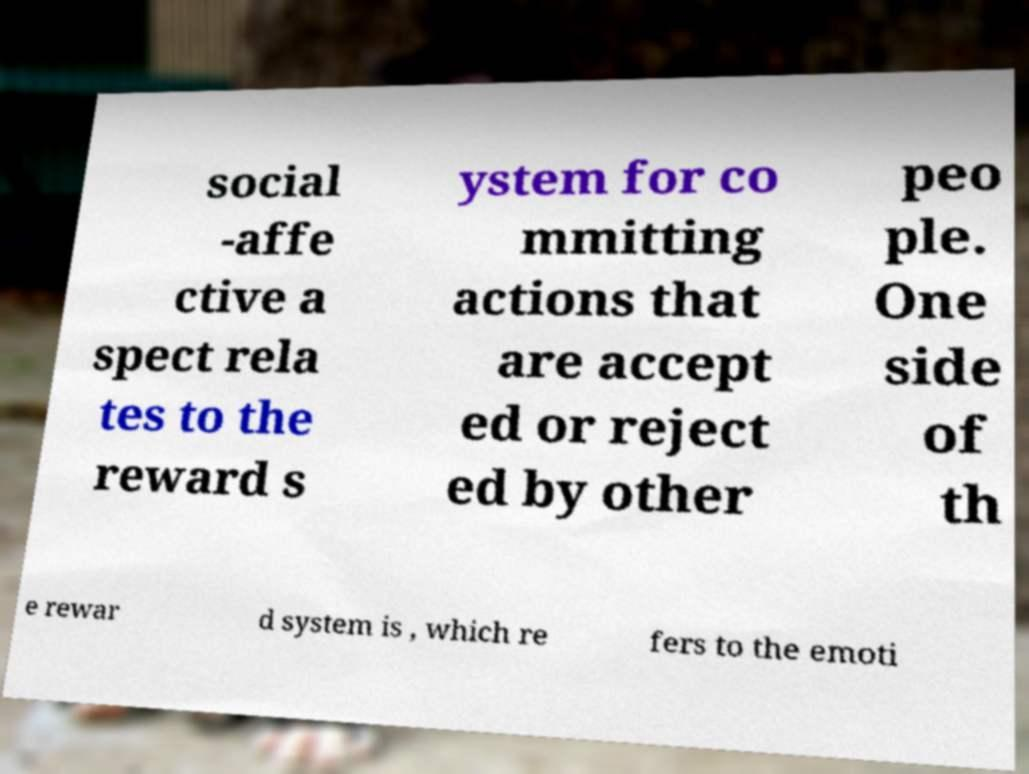Can you read and provide the text displayed in the image?This photo seems to have some interesting text. Can you extract and type it out for me? social -affe ctive a spect rela tes to the reward s ystem for co mmitting actions that are accept ed or reject ed by other peo ple. One side of th e rewar d system is , which re fers to the emoti 